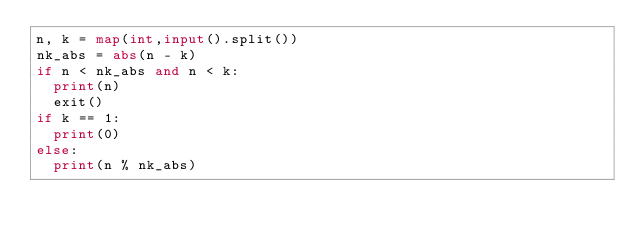<code> <loc_0><loc_0><loc_500><loc_500><_Python_>n, k = map(int,input().split())
nk_abs = abs(n - k)
if n < nk_abs and n < k:
  print(n)
  exit()
if k == 1:
  print(0)
else:
  print(n % nk_abs)</code> 